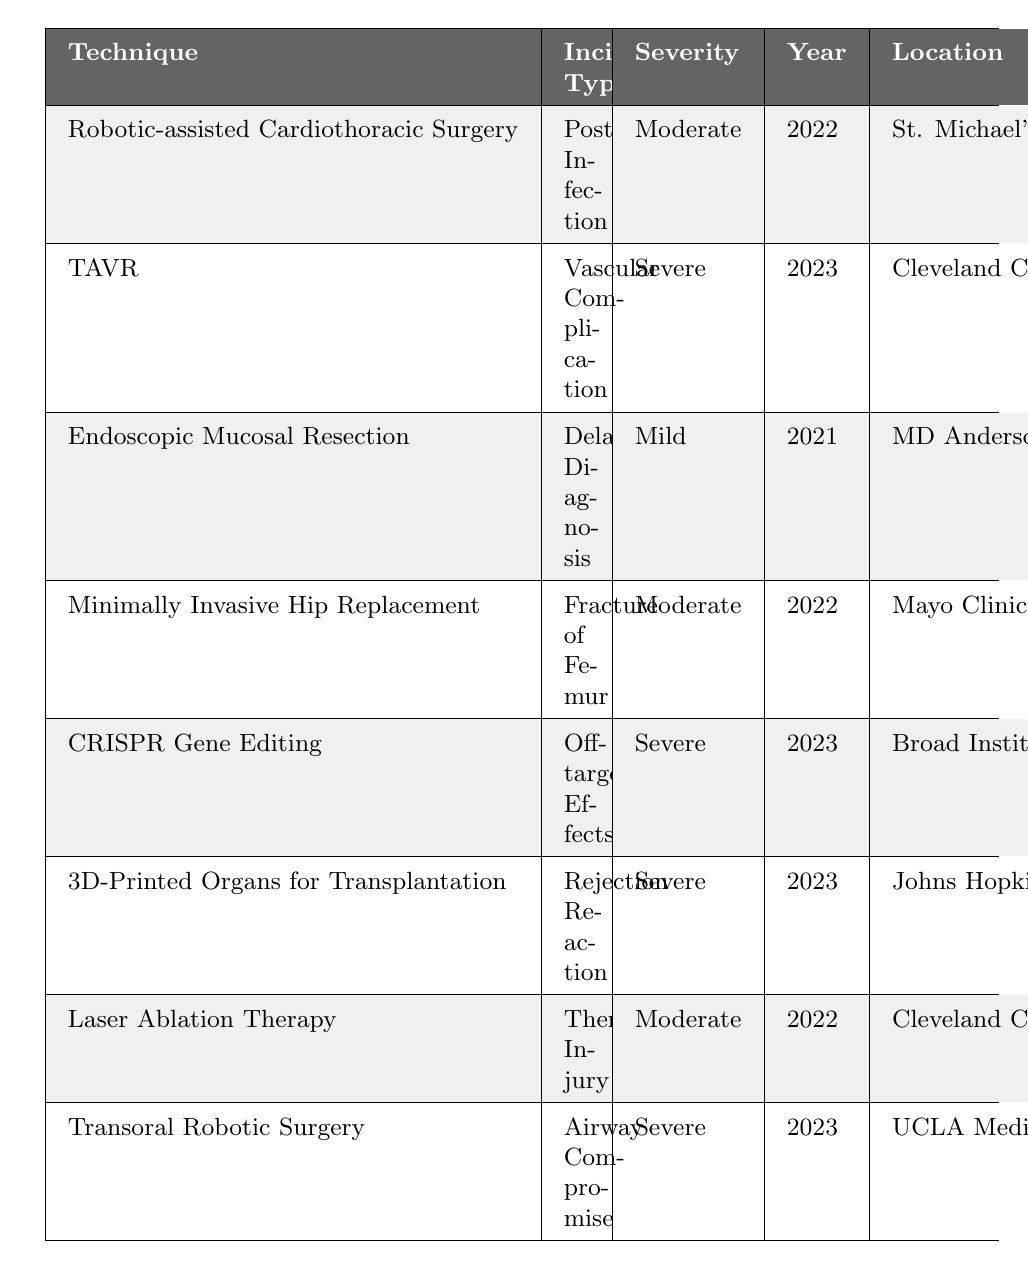What is the incident type associated with the CRISPR Gene Editing technique? The table shows that the incident type for CRISPR Gene Editing is "Off-target Effects."
Answer: Off-target Effects In which year did the vascular complication incident occur? The table indicates that the vascular complication incident happened in the year 2023 under the TAVR technique.
Answer: 2023 How many total severe incidents are listed in the table? There are 5 incidents labeled as "Severe" in the table: TAVR, CRISPR Gene Editing, 3D-Printed Organs for Transplantation, Laser Ablation Therapy, and Transoral Robotic Surgery.
Answer: 4 Which surgical technique had a moderate severity incident in 2022? The table lists that both Robotic-assisted Cardiothoracic Surgery and Minimally Invasive Hip Replacement had moderate severity incidents in 2022.
Answer: Two techniques Was there any incident of delayed diagnosis reported? Yes, the table states that there was an incident of delayed diagnosis related to Endoscopic Mucosal Resection (EMR).
Answer: Yes What is the location of the incident involving thermal injury? According to the table, the thermal injury incident occurred at the Cleveland Clinic, Ohio.
Answer: Cleveland Clinic, Ohio Among the incidents listed, which one is related to a rejection reaction? The incident related to a rejection reaction is part of the 3D-Printed Organs for Transplantation procedure according to the table.
Answer: 3D-Printed Organs for Transplantation How many different locations are mentioned for the incidents? The table lists incidents occurring in 6 different locations: St. Michael's Hospital, Cleveland Clinic, MD Anderson Cancer Center, Mayo Clinic, Broad Institute, Johns Hopkins Hospital, and UCLA Medical Center.
Answer: 8 locations Which incident occurred at UCLA Medical Center? The table shows that the incident at UCLA Medical Center pertains to Airway Compromise as part of Transoral Robotic Surgery.
Answer: Airway Compromise What is the severity of the incident mentioned for Endoscopic Mucosal Resection? The severity level for the incident related to Endoscopic Mucosal Resection is categorized as "Mild."
Answer: Mild Which incident involved significant blood loss? The TAVR incident involved a major vascular injury, leading to significant blood loss, as described in the table.
Answer: TAVR 